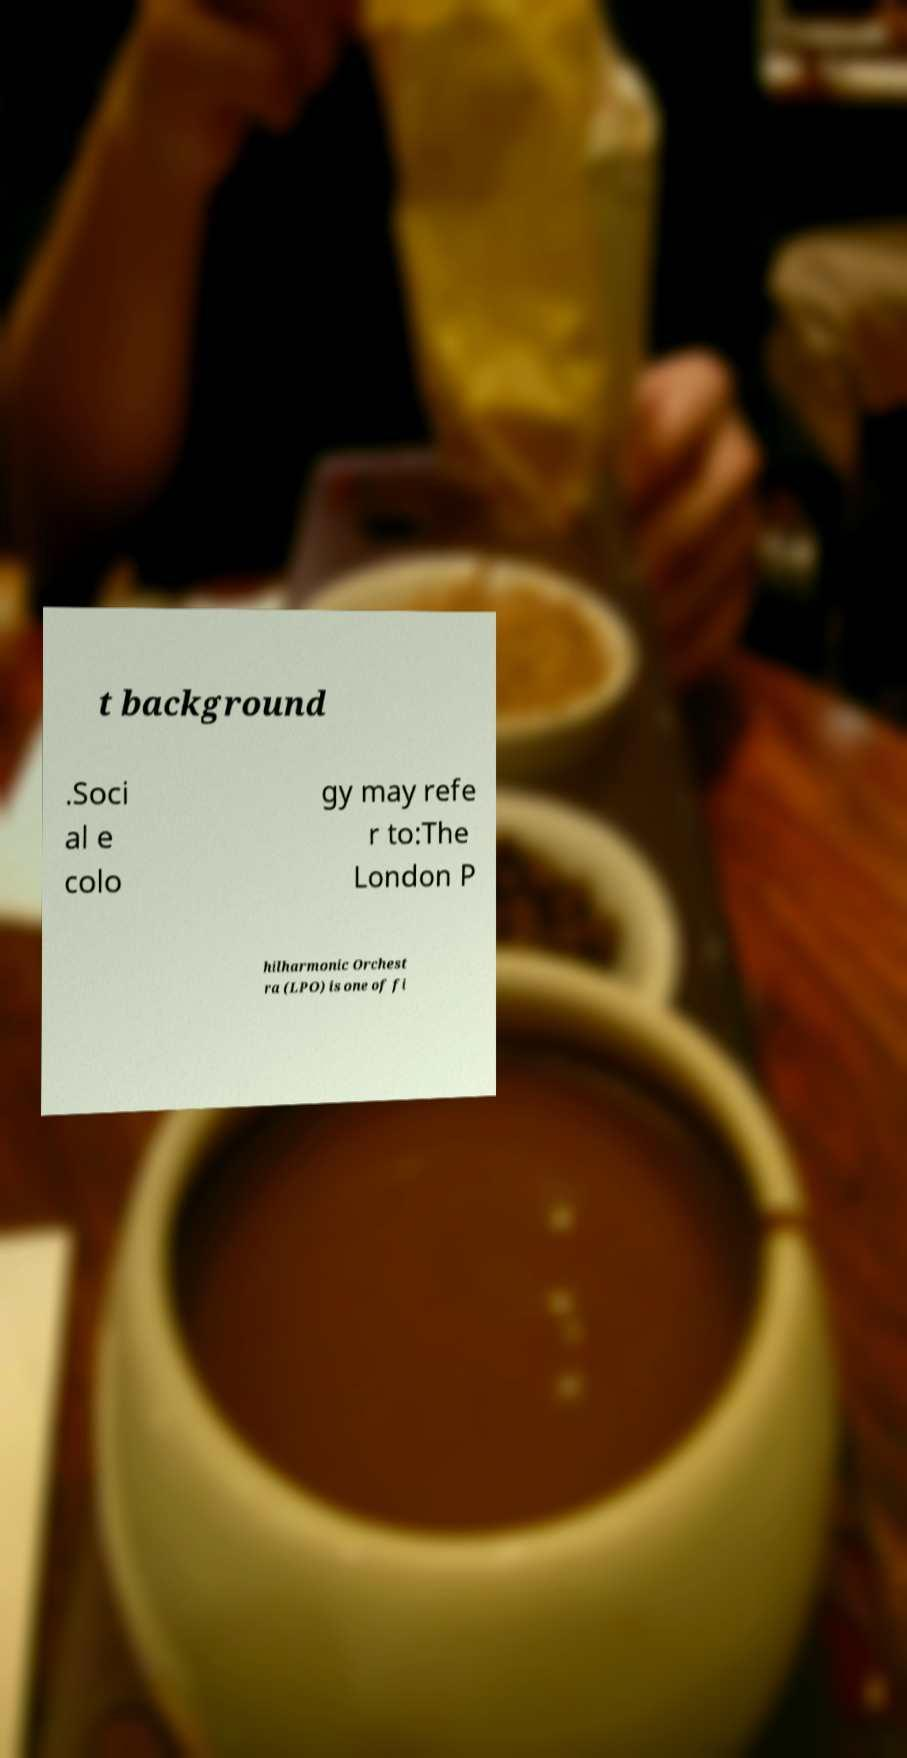Please read and relay the text visible in this image. What does it say? t background .Soci al e colo gy may refe r to:The London P hilharmonic Orchest ra (LPO) is one of fi 